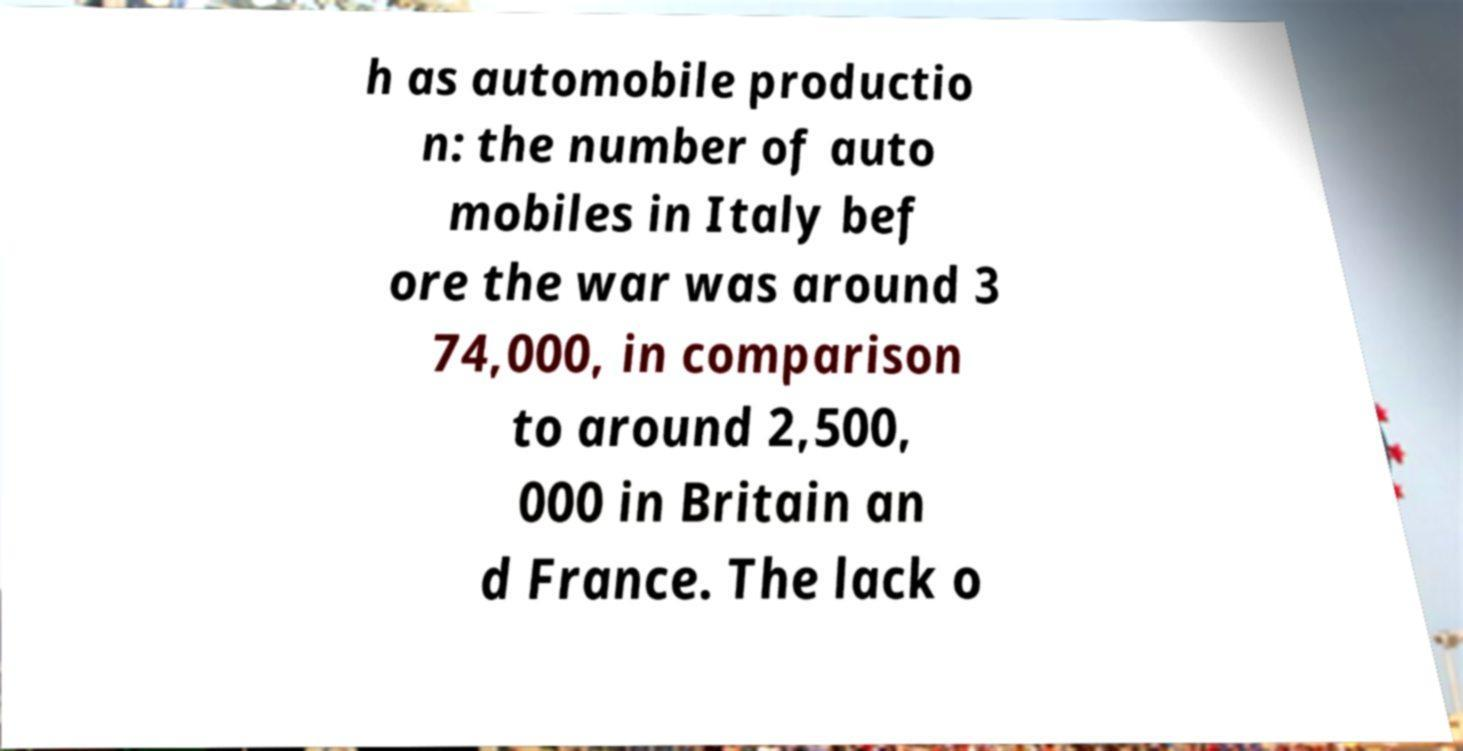What messages or text are displayed in this image? I need them in a readable, typed format. h as automobile productio n: the number of auto mobiles in Italy bef ore the war was around 3 74,000, in comparison to around 2,500, 000 in Britain an d France. The lack o 